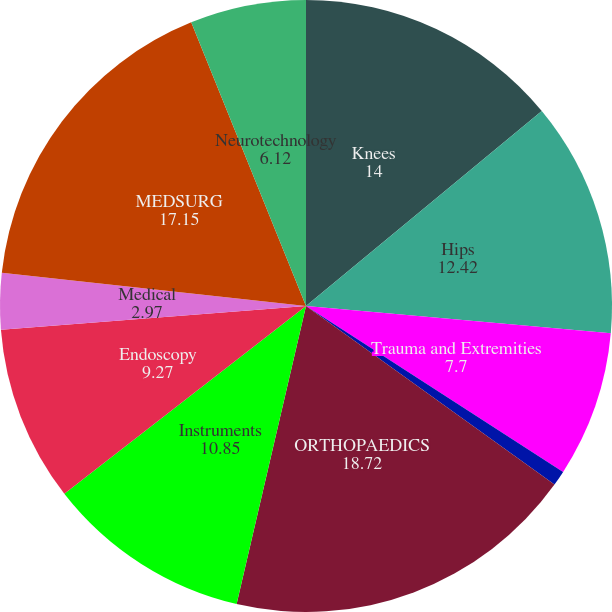Convert chart to OTSL. <chart><loc_0><loc_0><loc_500><loc_500><pie_chart><fcel>Knees<fcel>Hips<fcel>Trauma and Extremities<fcel>Other<fcel>ORTHOPAEDICS<fcel>Instruments<fcel>Endoscopy<fcel>Medical<fcel>MEDSURG<fcel>Neurotechnology<nl><fcel>14.0%<fcel>12.42%<fcel>7.7%<fcel>0.8%<fcel>18.72%<fcel>10.85%<fcel>9.27%<fcel>2.97%<fcel>17.15%<fcel>6.12%<nl></chart> 